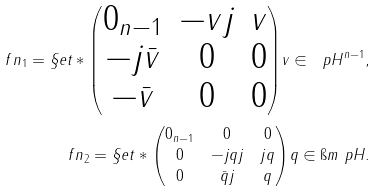<formula> <loc_0><loc_0><loc_500><loc_500>\ f { n } _ { 1 } = \S e t * { \begin{pmatrix} 0 _ { n - 1 } & - v j & v \\ - j \bar { v } & 0 & 0 \\ - \bar { v } & 0 & 0 \end{pmatrix} } { v \in \ p H ^ { n - 1 } } , \\ \ f { n } _ { 2 } = \S e t * { \begin{pmatrix} 0 _ { n - 1 } & 0 & 0 \\ 0 & - j q j & j q \\ 0 & \bar { q } j & q \end{pmatrix} } { q \in \i m \ p H } .</formula> 